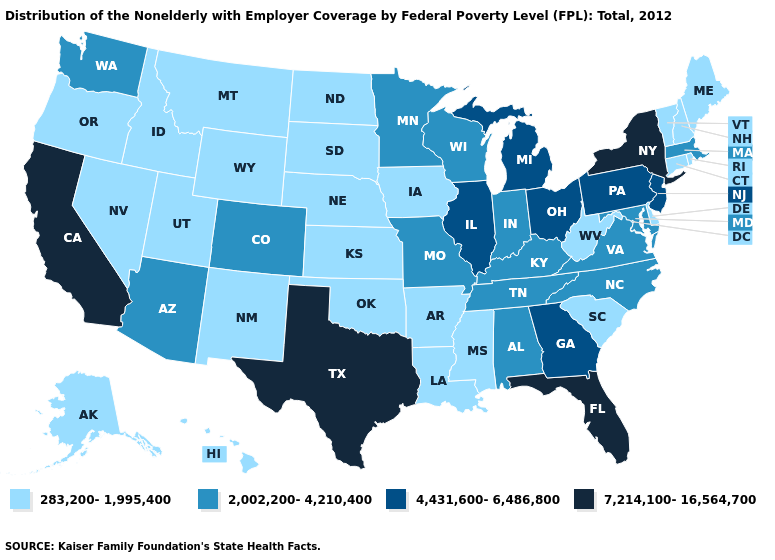Does Illinois have the same value as Georgia?
Answer briefly. Yes. Does Florida have the highest value in the USA?
Short answer required. Yes. Among the states that border Nevada , which have the lowest value?
Keep it brief. Idaho, Oregon, Utah. Does Minnesota have the highest value in the MidWest?
Quick response, please. No. What is the lowest value in states that border Arkansas?
Write a very short answer. 283,200-1,995,400. Does the map have missing data?
Write a very short answer. No. What is the value of Delaware?
Give a very brief answer. 283,200-1,995,400. What is the value of Iowa?
Be succinct. 283,200-1,995,400. Does Arizona have a higher value than Kansas?
Concise answer only. Yes. Does Colorado have a higher value than North Dakota?
Be succinct. Yes. Does the map have missing data?
Keep it brief. No. Name the states that have a value in the range 4,431,600-6,486,800?
Be succinct. Georgia, Illinois, Michigan, New Jersey, Ohio, Pennsylvania. Does Rhode Island have the same value as Vermont?
Answer briefly. Yes. What is the value of Kentucky?
Give a very brief answer. 2,002,200-4,210,400. Does Colorado have the lowest value in the USA?
Answer briefly. No. 